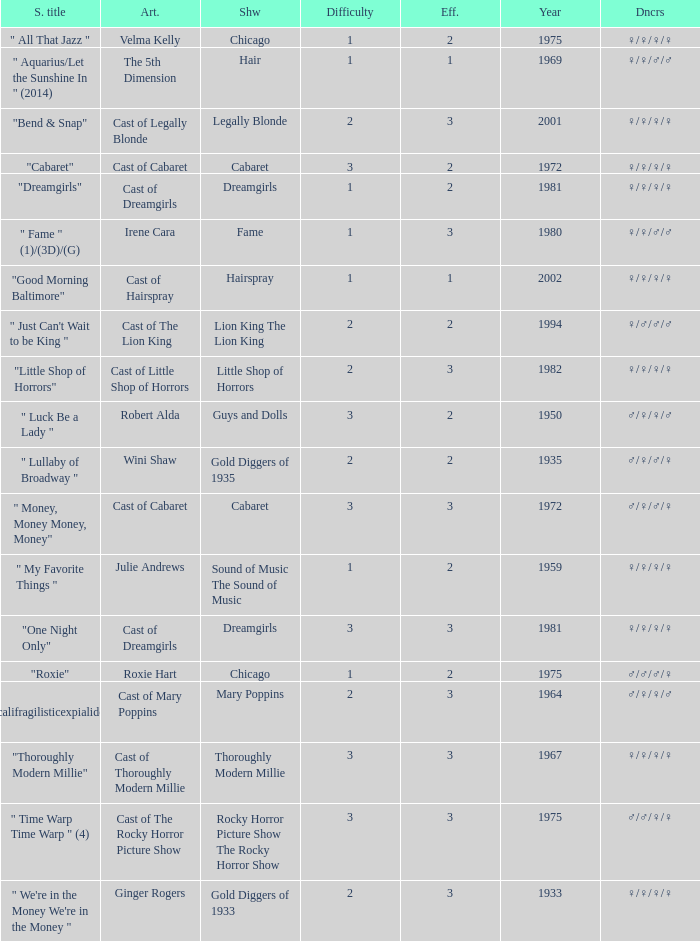How many artists were there for the show thoroughly modern millie? 1.0. 